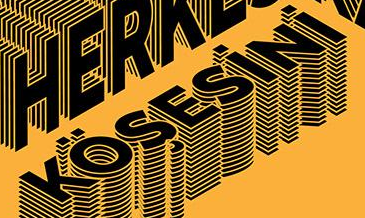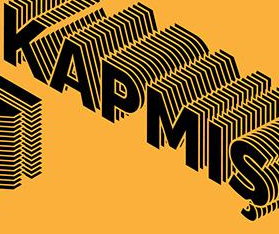What words can you see in these images in sequence, separated by a semicolon? KÖŞESiNi; KAPMIŞ 